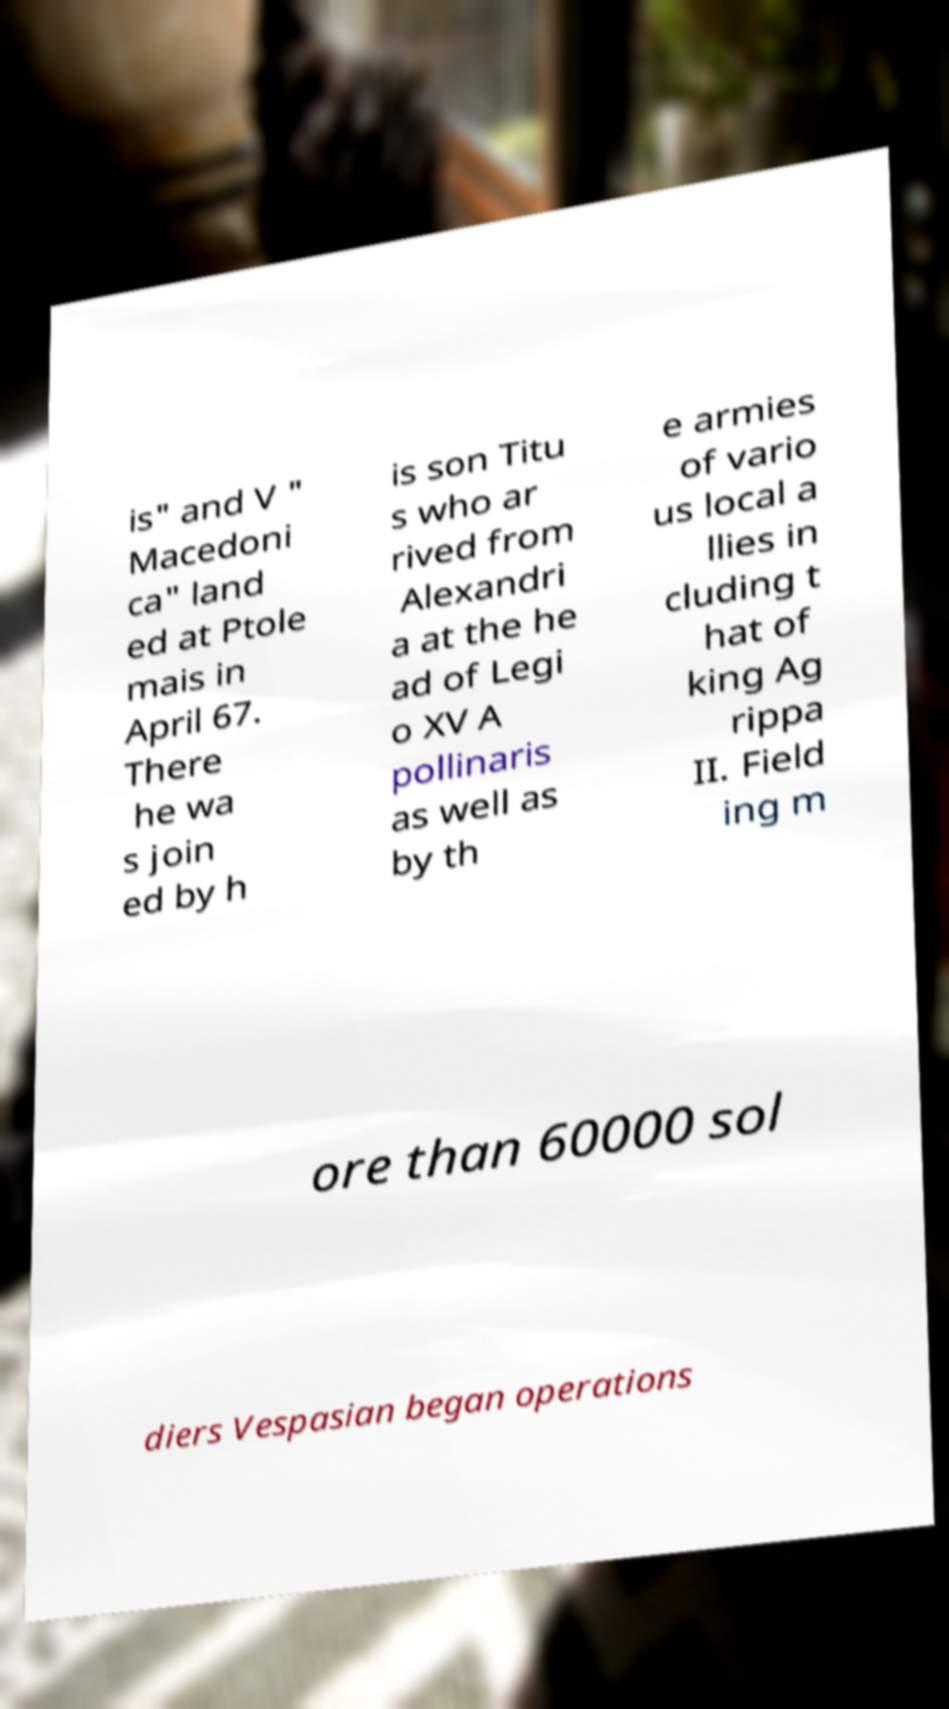Please identify and transcribe the text found in this image. is" and V " Macedoni ca" land ed at Ptole mais in April 67. There he wa s join ed by h is son Titu s who ar rived from Alexandri a at the he ad of Legi o XV A pollinaris as well as by th e armies of vario us local a llies in cluding t hat of king Ag rippa II. Field ing m ore than 60000 sol diers Vespasian began operations 